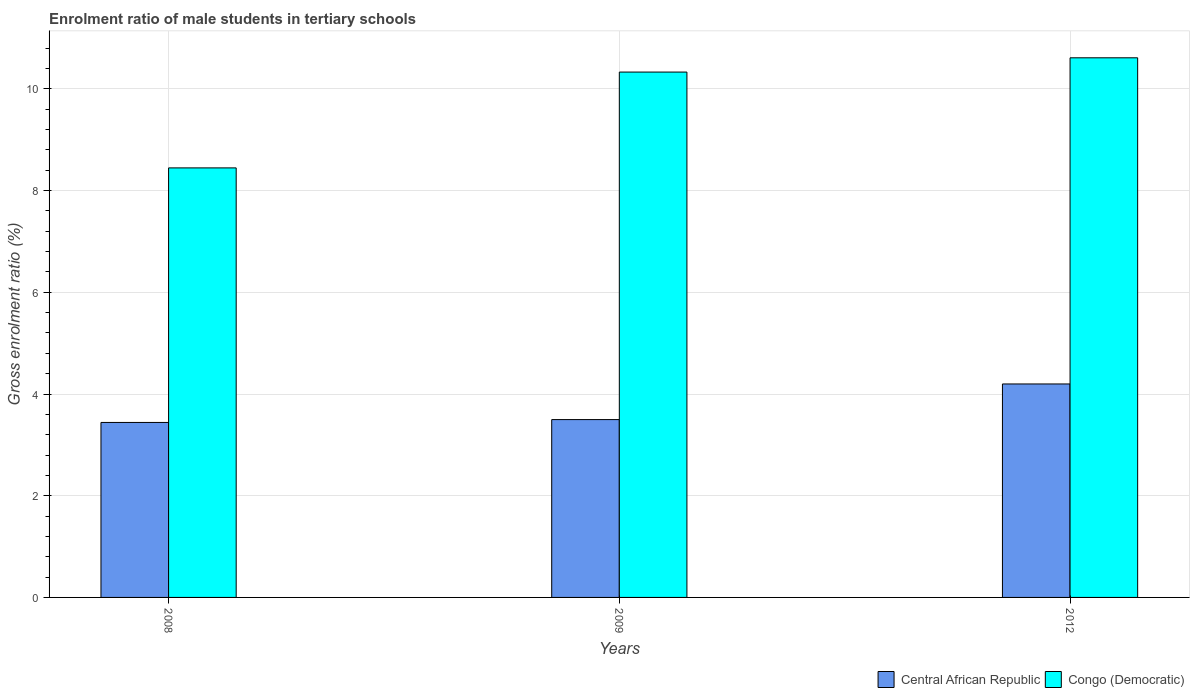How many bars are there on the 1st tick from the left?
Provide a succinct answer. 2. In how many cases, is the number of bars for a given year not equal to the number of legend labels?
Your response must be concise. 0. What is the enrolment ratio of male students in tertiary schools in Central African Republic in 2009?
Give a very brief answer. 3.5. Across all years, what is the maximum enrolment ratio of male students in tertiary schools in Congo (Democratic)?
Your response must be concise. 10.61. Across all years, what is the minimum enrolment ratio of male students in tertiary schools in Congo (Democratic)?
Offer a very short reply. 8.45. In which year was the enrolment ratio of male students in tertiary schools in Congo (Democratic) maximum?
Keep it short and to the point. 2012. What is the total enrolment ratio of male students in tertiary schools in Central African Republic in the graph?
Offer a terse response. 11.14. What is the difference between the enrolment ratio of male students in tertiary schools in Congo (Democratic) in 2008 and that in 2012?
Your response must be concise. -2.16. What is the difference between the enrolment ratio of male students in tertiary schools in Central African Republic in 2009 and the enrolment ratio of male students in tertiary schools in Congo (Democratic) in 2012?
Offer a terse response. -7.11. What is the average enrolment ratio of male students in tertiary schools in Congo (Democratic) per year?
Your response must be concise. 9.8. In the year 2009, what is the difference between the enrolment ratio of male students in tertiary schools in Central African Republic and enrolment ratio of male students in tertiary schools in Congo (Democratic)?
Keep it short and to the point. -6.83. What is the ratio of the enrolment ratio of male students in tertiary schools in Central African Republic in 2008 to that in 2012?
Keep it short and to the point. 0.82. What is the difference between the highest and the second highest enrolment ratio of male students in tertiary schools in Central African Republic?
Provide a short and direct response. 0.7. What is the difference between the highest and the lowest enrolment ratio of male students in tertiary schools in Congo (Democratic)?
Make the answer very short. 2.16. In how many years, is the enrolment ratio of male students in tertiary schools in Congo (Democratic) greater than the average enrolment ratio of male students in tertiary schools in Congo (Democratic) taken over all years?
Ensure brevity in your answer.  2. What does the 1st bar from the left in 2008 represents?
Provide a succinct answer. Central African Republic. What does the 2nd bar from the right in 2008 represents?
Provide a succinct answer. Central African Republic. How many bars are there?
Give a very brief answer. 6. Are the values on the major ticks of Y-axis written in scientific E-notation?
Your response must be concise. No. Does the graph contain any zero values?
Make the answer very short. No. Does the graph contain grids?
Provide a short and direct response. Yes. What is the title of the graph?
Offer a terse response. Enrolment ratio of male students in tertiary schools. What is the label or title of the X-axis?
Make the answer very short. Years. What is the Gross enrolment ratio (%) in Central African Republic in 2008?
Your response must be concise. 3.44. What is the Gross enrolment ratio (%) of Congo (Democratic) in 2008?
Ensure brevity in your answer.  8.45. What is the Gross enrolment ratio (%) in Central African Republic in 2009?
Offer a terse response. 3.5. What is the Gross enrolment ratio (%) in Congo (Democratic) in 2009?
Your answer should be very brief. 10.33. What is the Gross enrolment ratio (%) in Central African Republic in 2012?
Offer a terse response. 4.2. What is the Gross enrolment ratio (%) in Congo (Democratic) in 2012?
Your response must be concise. 10.61. Across all years, what is the maximum Gross enrolment ratio (%) in Central African Republic?
Your answer should be compact. 4.2. Across all years, what is the maximum Gross enrolment ratio (%) in Congo (Democratic)?
Provide a short and direct response. 10.61. Across all years, what is the minimum Gross enrolment ratio (%) of Central African Republic?
Offer a terse response. 3.44. Across all years, what is the minimum Gross enrolment ratio (%) of Congo (Democratic)?
Your answer should be very brief. 8.45. What is the total Gross enrolment ratio (%) of Central African Republic in the graph?
Keep it short and to the point. 11.14. What is the total Gross enrolment ratio (%) of Congo (Democratic) in the graph?
Make the answer very short. 29.39. What is the difference between the Gross enrolment ratio (%) of Central African Republic in 2008 and that in 2009?
Give a very brief answer. -0.06. What is the difference between the Gross enrolment ratio (%) in Congo (Democratic) in 2008 and that in 2009?
Ensure brevity in your answer.  -1.88. What is the difference between the Gross enrolment ratio (%) of Central African Republic in 2008 and that in 2012?
Offer a very short reply. -0.76. What is the difference between the Gross enrolment ratio (%) of Congo (Democratic) in 2008 and that in 2012?
Ensure brevity in your answer.  -2.16. What is the difference between the Gross enrolment ratio (%) of Central African Republic in 2009 and that in 2012?
Provide a short and direct response. -0.7. What is the difference between the Gross enrolment ratio (%) in Congo (Democratic) in 2009 and that in 2012?
Your answer should be compact. -0.28. What is the difference between the Gross enrolment ratio (%) of Central African Republic in 2008 and the Gross enrolment ratio (%) of Congo (Democratic) in 2009?
Your answer should be very brief. -6.89. What is the difference between the Gross enrolment ratio (%) in Central African Republic in 2008 and the Gross enrolment ratio (%) in Congo (Democratic) in 2012?
Make the answer very short. -7.17. What is the difference between the Gross enrolment ratio (%) of Central African Republic in 2009 and the Gross enrolment ratio (%) of Congo (Democratic) in 2012?
Your answer should be very brief. -7.11. What is the average Gross enrolment ratio (%) in Central African Republic per year?
Your response must be concise. 3.71. What is the average Gross enrolment ratio (%) of Congo (Democratic) per year?
Provide a succinct answer. 9.8. In the year 2008, what is the difference between the Gross enrolment ratio (%) of Central African Republic and Gross enrolment ratio (%) of Congo (Democratic)?
Your response must be concise. -5.01. In the year 2009, what is the difference between the Gross enrolment ratio (%) of Central African Republic and Gross enrolment ratio (%) of Congo (Democratic)?
Offer a very short reply. -6.83. In the year 2012, what is the difference between the Gross enrolment ratio (%) of Central African Republic and Gross enrolment ratio (%) of Congo (Democratic)?
Ensure brevity in your answer.  -6.41. What is the ratio of the Gross enrolment ratio (%) of Central African Republic in 2008 to that in 2009?
Offer a terse response. 0.98. What is the ratio of the Gross enrolment ratio (%) of Congo (Democratic) in 2008 to that in 2009?
Ensure brevity in your answer.  0.82. What is the ratio of the Gross enrolment ratio (%) of Central African Republic in 2008 to that in 2012?
Provide a succinct answer. 0.82. What is the ratio of the Gross enrolment ratio (%) of Congo (Democratic) in 2008 to that in 2012?
Make the answer very short. 0.8. What is the ratio of the Gross enrolment ratio (%) of Central African Republic in 2009 to that in 2012?
Offer a terse response. 0.83. What is the ratio of the Gross enrolment ratio (%) of Congo (Democratic) in 2009 to that in 2012?
Provide a succinct answer. 0.97. What is the difference between the highest and the second highest Gross enrolment ratio (%) of Central African Republic?
Ensure brevity in your answer.  0.7. What is the difference between the highest and the second highest Gross enrolment ratio (%) of Congo (Democratic)?
Your answer should be very brief. 0.28. What is the difference between the highest and the lowest Gross enrolment ratio (%) of Central African Republic?
Keep it short and to the point. 0.76. What is the difference between the highest and the lowest Gross enrolment ratio (%) in Congo (Democratic)?
Your response must be concise. 2.16. 